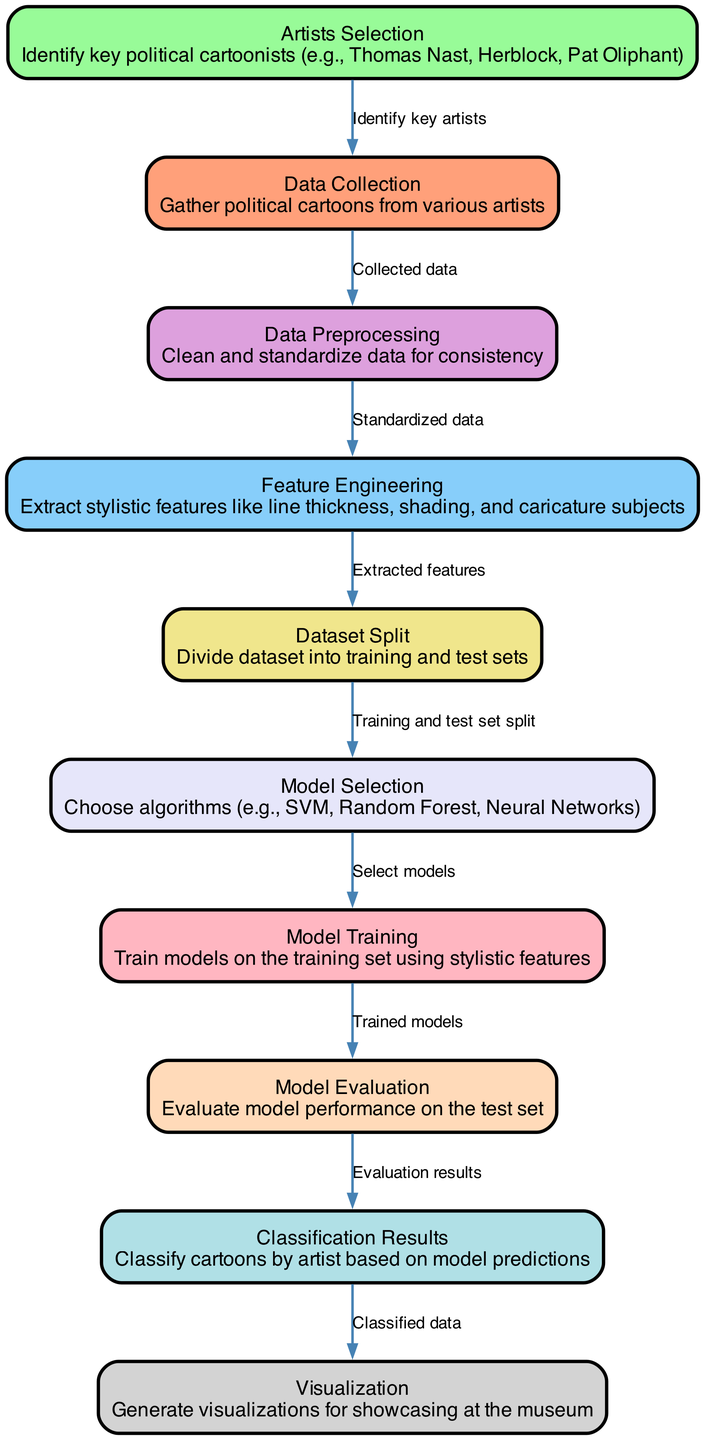What is the first step in the process? The first step in the machine learning process is "Data Collection," where political cartoons from various artists are gathered. This is indicated as the starting node in the diagram.
Answer: Data Collection How many nodes are in the diagram? By counting all the unique nodes present in the diagram, we find that there are ten nodes representing different stages of the machine learning process.
Answer: Ten Which node follows Data Preprocessing? The node that follows "Data Preprocessing" is "Feature Engineering," indicating that after cleaning and standardizing the data, stylistic features are extracted.
Answer: Feature Engineering What is the purpose of the Model Evaluation node? The purpose of the "Model Evaluation" node is to assess the performance of the trained models on the test set, ensuring that they can accurately classify the data.
Answer: Assess model performance How does Dataset Split connect to Model Selection? The connection from "Dataset Split" to "Model Selection" signifies that once the dataset is divided into training and test sets, the next step is to select appropriate algorithms for modeling.
Answer: By training and test set split What type of algorithms are chosen during the Model Selection? During the "Model Selection" stage, different algorithms, specifically Support Vector Machines, Random Forests, and Neural Networks, are chosen for the classification task.
Answer: SVM, Random Forest, Neural Networks What is the final outcome of the process depicted in the diagram? The final outcome of the process is the "Classification Results," where political cartoons are classified by artist based on the model’s predictions. This reflects the ultimate goal of the entire workflow.
Answer: Classification Results Which node leads to the creation of visualizations for the museum? The node that leads to the creation of visualizations for the museum is "Classification Results," as it provides the classified data necessary for visualization.
Answer: Classification Results What type of data is utilized in Feature Engineering? In "Feature Engineering," stylistic features such as line thickness, shading, and caricature subjects are extracted from the cleaned data to assist in the classification of political cartoons.
Answer: Stylistic features 